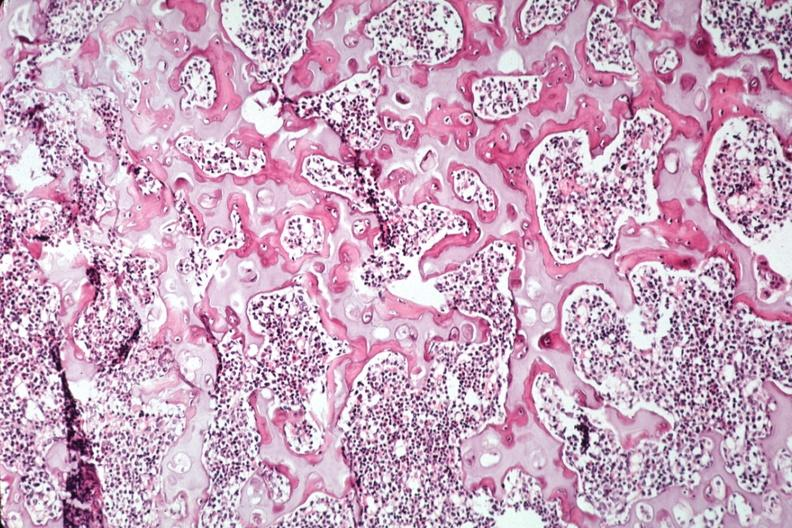s pagets disease present?
Answer the question using a single word or phrase. No 